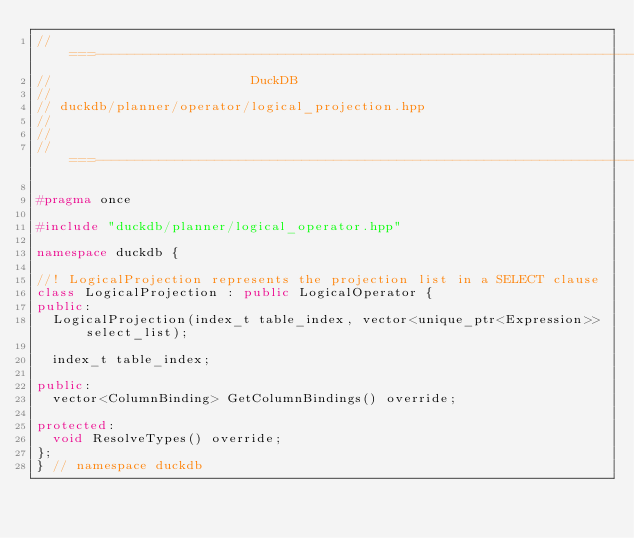<code> <loc_0><loc_0><loc_500><loc_500><_C++_>//===----------------------------------------------------------------------===//
//                         DuckDB
//
// duckdb/planner/operator/logical_projection.hpp
//
//
//===----------------------------------------------------------------------===//

#pragma once

#include "duckdb/planner/logical_operator.hpp"

namespace duckdb {

//! LogicalProjection represents the projection list in a SELECT clause
class LogicalProjection : public LogicalOperator {
public:
	LogicalProjection(index_t table_index, vector<unique_ptr<Expression>> select_list);

	index_t table_index;

public:
	vector<ColumnBinding> GetColumnBindings() override;

protected:
	void ResolveTypes() override;
};
} // namespace duckdb
</code> 